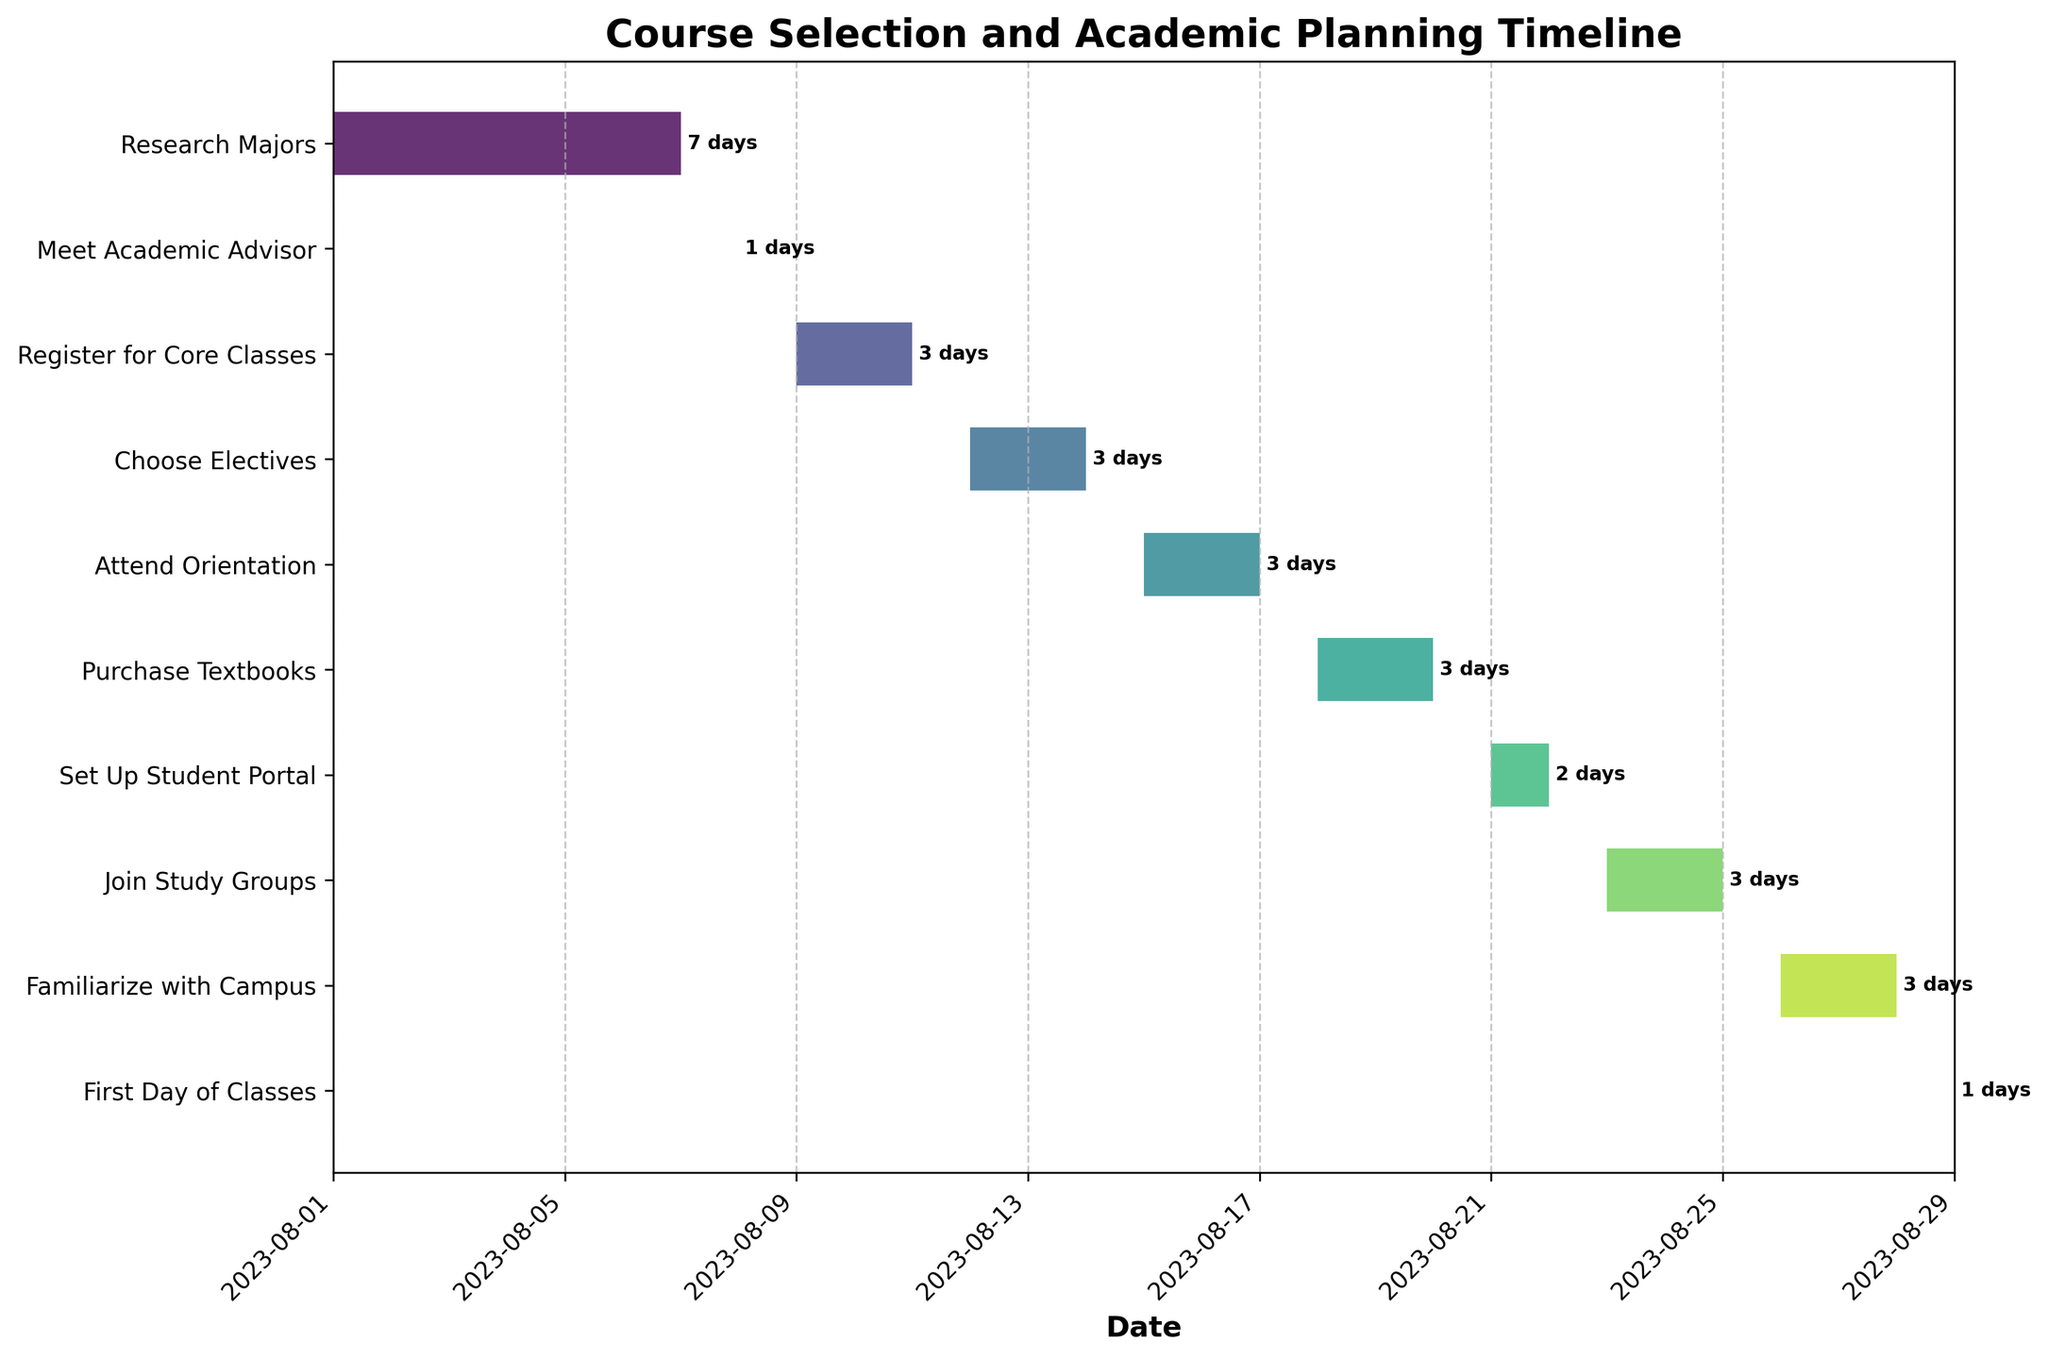How many tasks are displayed in the Gantt Chart? Count the number of horizontal bars in the chart that correspond to different tasks. There are 10 distinct tasks listed.
Answer: 10 What is the title of the Gantt Chart? Look at the top of the figure for the title text. The title is 'Course Selection and Academic Planning Timeline'.
Answer: Course Selection and Academic Planning Timeline How long does the "Register for Core Classes" task take? Find the "Register for Core Classes" task in the Gantt Chart and read its duration label. The duration is 3 days.
Answer: 3 days Which task takes the longest to complete? Compare the duration of each task by looking at the horizontal bars and labels. "Research Majors" has the longest duration of 7 days.
Answer: Research Majors What is the last task before the first day of classes? Locate the "First Day of Classes" task and identify the task immediately before it in the sequence. The preceding task is "Familiarize with Campus".
Answer: Familiarize with Campus Between which dates does the "Attend Orientation" task take place? Find the "Attend Orientation" task in the chart and identify its start and end dates. The dates are from August 15 to August 17.
Answer: August 15 to August 17 How many tasks start in the month of August? Count the number of tasks with start dates in August by looking at the timeline axis. All tasks start in August.
Answer: 10 What is the average duration of all tasks? Sum the durations of all tasks and divide by the number of tasks. Sum of durations is \(7 + 1 + 3 + 3 + 3 + 3 + 2 + 3 + 3 + 1 = 29\) days. Average is \(29/10 = 2.9\) days.
Answer: 2.9 days Compare the durations of "Meet Academic Advisor" and "Set Up Student Portal". Which task takes longer? Locate the tasks "Meet Academic Advisor" and "Set Up Student Portal" and compare their duration labels. "Set Up Student Portal" takes longer with 2 days compared to 1 day for "Meet Academic Advisor".
Answer: Set Up Student Portal Which tasks have the same duration and what is that duration? Identify tasks with identical durations by comparing the labels on the bars. "Register for Core Classes", "Choose Electives", "Attend Orientation", "Purchase Textbooks", "Join Study Groups", "Familiarize with Campus" all have a duration of 3 days.
Answer: 3 days, and the tasks are Register for Core Classes, Choose Electives, Attend Orientation, Purchase Textbooks, Join Study Groups, Familiarize with Campus 